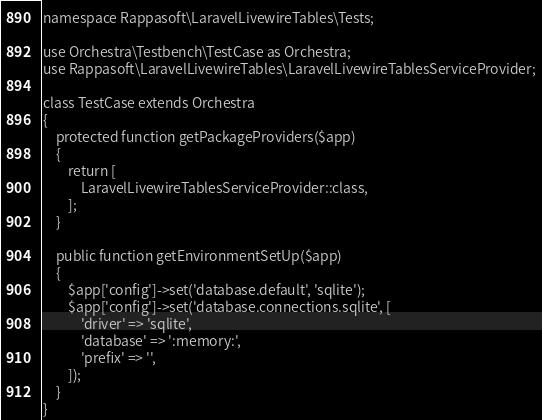<code> <loc_0><loc_0><loc_500><loc_500><_PHP_>
namespace Rappasoft\LaravelLivewireTables\Tests;

use Orchestra\Testbench\TestCase as Orchestra;
use Rappasoft\LaravelLivewireTables\LaravelLivewireTablesServiceProvider;

class TestCase extends Orchestra
{
    protected function getPackageProviders($app)
    {
        return [
            LaravelLivewireTablesServiceProvider::class,
        ];
    }

    public function getEnvironmentSetUp($app)
    {
        $app['config']->set('database.default', 'sqlite');
        $app['config']->set('database.connections.sqlite', [
            'driver' => 'sqlite',
            'database' => ':memory:',
            'prefix' => '',
        ]);
    }
}
</code> 